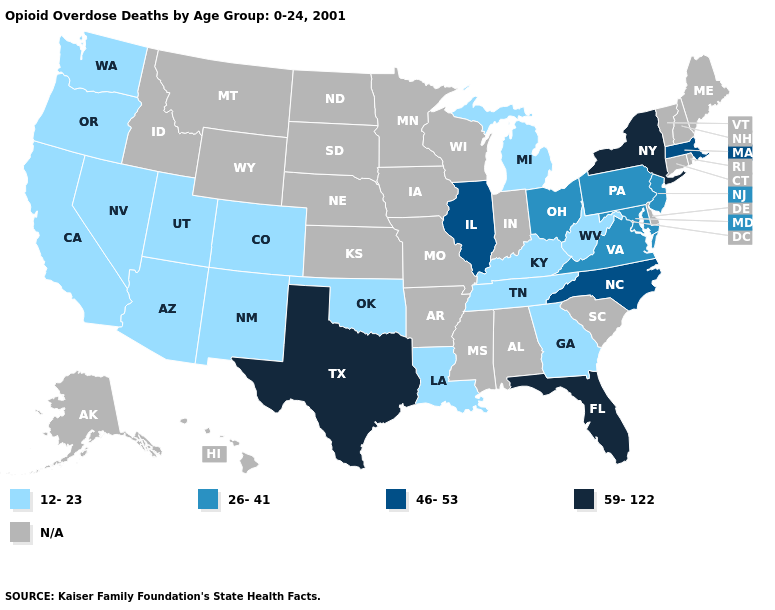What is the value of Alaska?
Quick response, please. N/A. Name the states that have a value in the range 46-53?
Concise answer only. Illinois, Massachusetts, North Carolina. What is the value of Florida?
Be succinct. 59-122. Name the states that have a value in the range 59-122?
Give a very brief answer. Florida, New York, Texas. What is the lowest value in the South?
Concise answer only. 12-23. Name the states that have a value in the range 12-23?
Write a very short answer. Arizona, California, Colorado, Georgia, Kentucky, Louisiana, Michigan, Nevada, New Mexico, Oklahoma, Oregon, Tennessee, Utah, Washington, West Virginia. What is the highest value in the MidWest ?
Write a very short answer. 46-53. What is the lowest value in states that border Kansas?
Concise answer only. 12-23. What is the value of Ohio?
Be succinct. 26-41. Among the states that border Illinois , which have the lowest value?
Quick response, please. Kentucky. What is the highest value in states that border Michigan?
Concise answer only. 26-41. Name the states that have a value in the range 59-122?
Concise answer only. Florida, New York, Texas. Name the states that have a value in the range 46-53?
Keep it brief. Illinois, Massachusetts, North Carolina. What is the value of New Jersey?
Answer briefly. 26-41. 